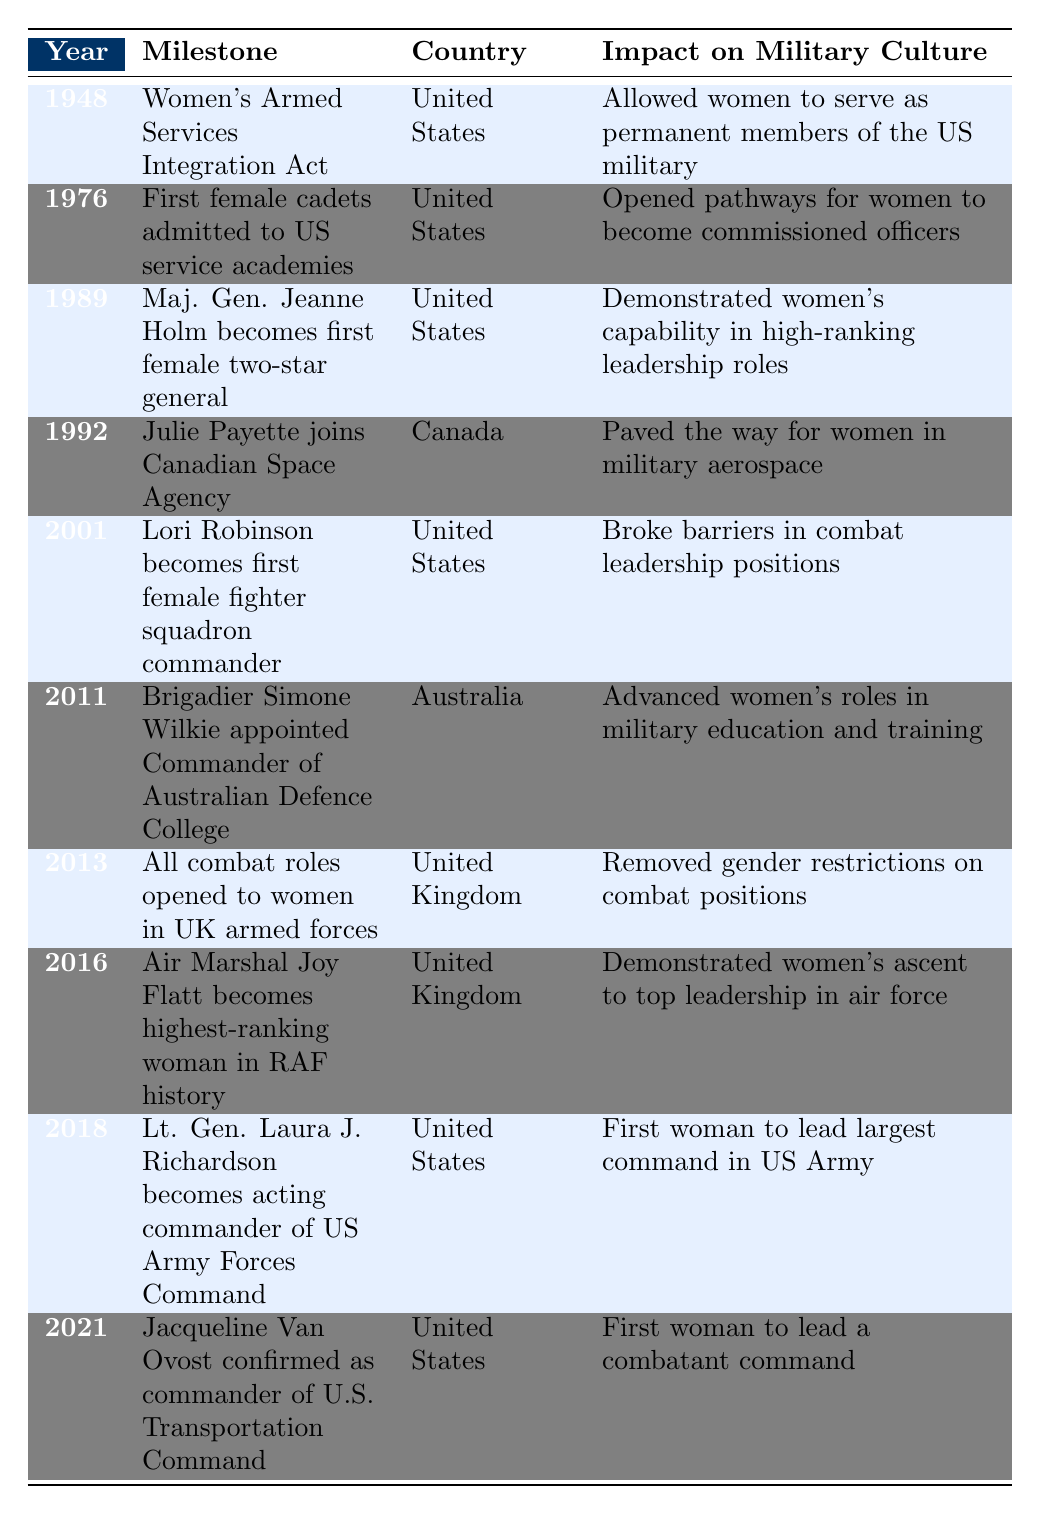What year did the Women's Armed Services Integration Act pass? The table lists 1948 as the year for the Women's Armed Services Integration Act in the United States.
Answer: 1948 Which country first admitted female cadets to their service academies? The table states that the United States was the country that first admitted female cadets in 1976.
Answer: United States How many milestones were recorded for the United States in the table? The table includes seven milestones specifically related to the United States.
Answer: 7 What was the impact of the 2013 milestone in the UK? The table outlines that in 2013, all combat roles were opened to women in the UK armed forces, which removed gender restrictions on combat positions.
Answer: Removed gender restrictions on combat positions Did any milestone occur in Canada, and if so, what was its significance? Yes, in 1992 Julie Payette joined the Canadian Space Agency, which paved the way for women in military aerospace.
Answer: Yes, it paved the way for women in military aerospace Which female leader became the first two-star general in the United States? Maj. Gen. Jeanne Holm is noted in the table as the first female two-star general in 1989.
Answer: Maj. Gen. Jeanne Holm What is the difference between the years 1989 and 2021, in terms of significant milestones for women in military leadership? The difference between 2021 and 1989 is 32 years, marking the time from the first female two-star general to the first woman to lead a combatant command.
Answer: 32 years Which country had a milestone related to military education and training in 2011? According to the table, Australia had a milestone in 2011 when Brigadier Simone Wilkie was appointed Commander of the Australian Defence College.
Answer: Australia What was the highest-ranking position achieved by Air Marshal Joy Flatt? The table indicates that she became the highest-ranking woman in RAF history in 2016.
Answer: Highest-ranking woman in RAF history List the years in which the US military witnessed female milestones related to combat leadership. The table shows milestones in 2001 and 2018 for the US military related to female combat leadership positions.
Answer: 2001 and 2018 In what context was Jacqueline Van Ovost's appointment in 2021 significant? The table records her as the first woman to lead a combatant command in the U.S. military.
Answer: First woman to lead a combatant command 